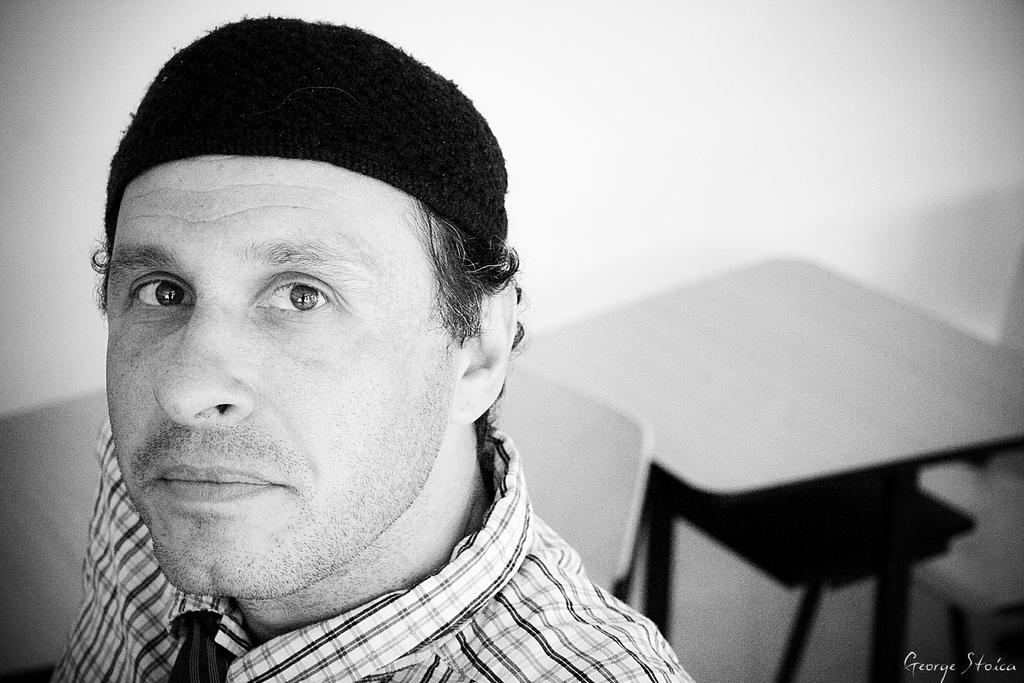What is the color of the wall in the image? The wall in the image is white. What type of furniture is present in the image? There is a chair and a table in the image. Who is present in the image? There is a man in the image. What type of clover is growing on the wall in the image? There is no clover present in the image; it is a white wall with no vegetation. 